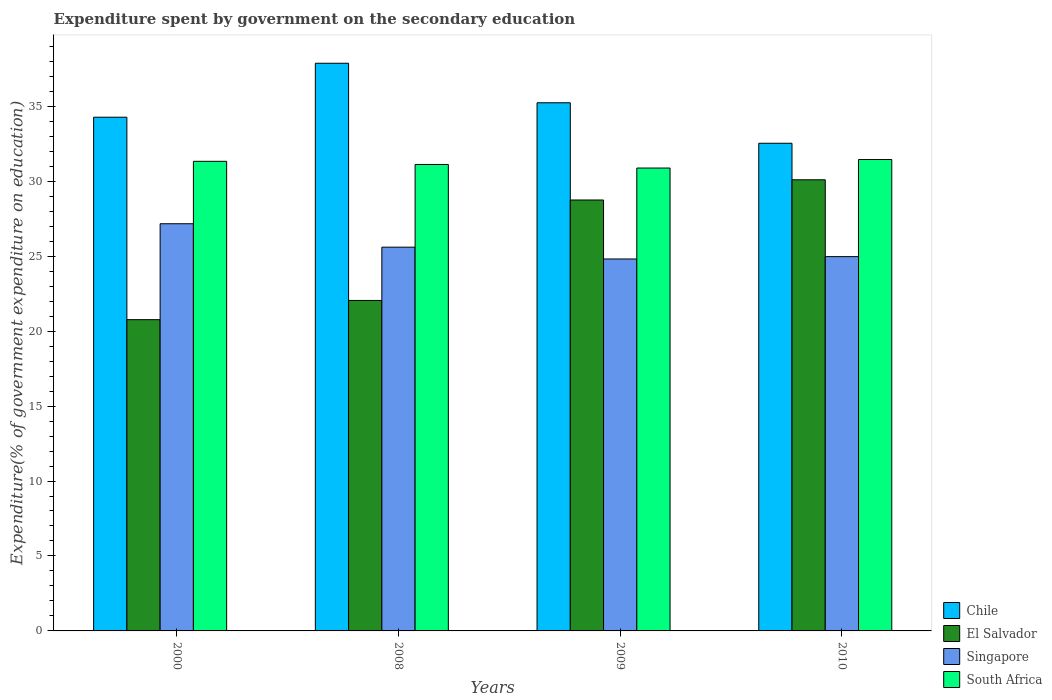Are the number of bars on each tick of the X-axis equal?
Make the answer very short. Yes. How many bars are there on the 3rd tick from the left?
Ensure brevity in your answer.  4. How many bars are there on the 4th tick from the right?
Make the answer very short. 4. What is the expenditure spent by government on the secondary education in Singapore in 2008?
Your answer should be very brief. 25.6. Across all years, what is the maximum expenditure spent by government on the secondary education in South Africa?
Provide a succinct answer. 31.45. Across all years, what is the minimum expenditure spent by government on the secondary education in Chile?
Ensure brevity in your answer.  32.53. What is the total expenditure spent by government on the secondary education in El Salvador in the graph?
Offer a terse response. 101.65. What is the difference between the expenditure spent by government on the secondary education in El Salvador in 2000 and that in 2009?
Your answer should be compact. -7.98. What is the difference between the expenditure spent by government on the secondary education in El Salvador in 2000 and the expenditure spent by government on the secondary education in Singapore in 2009?
Ensure brevity in your answer.  -4.05. What is the average expenditure spent by government on the secondary education in South Africa per year?
Ensure brevity in your answer.  31.19. In the year 2009, what is the difference between the expenditure spent by government on the secondary education in Singapore and expenditure spent by government on the secondary education in Chile?
Your answer should be compact. -10.42. In how many years, is the expenditure spent by government on the secondary education in Chile greater than 20 %?
Your response must be concise. 4. What is the ratio of the expenditure spent by government on the secondary education in El Salvador in 2000 to that in 2010?
Give a very brief answer. 0.69. Is the expenditure spent by government on the secondary education in Chile in 2009 less than that in 2010?
Provide a succinct answer. No. Is the difference between the expenditure spent by government on the secondary education in Singapore in 2000 and 2010 greater than the difference between the expenditure spent by government on the secondary education in Chile in 2000 and 2010?
Your response must be concise. Yes. What is the difference between the highest and the second highest expenditure spent by government on the secondary education in South Africa?
Ensure brevity in your answer.  0.12. What is the difference between the highest and the lowest expenditure spent by government on the secondary education in Singapore?
Provide a succinct answer. 2.35. Is it the case that in every year, the sum of the expenditure spent by government on the secondary education in Singapore and expenditure spent by government on the secondary education in South Africa is greater than the sum of expenditure spent by government on the secondary education in Chile and expenditure spent by government on the secondary education in El Salvador?
Your response must be concise. No. What does the 4th bar from the right in 2000 represents?
Offer a terse response. Chile. Is it the case that in every year, the sum of the expenditure spent by government on the secondary education in Singapore and expenditure spent by government on the secondary education in South Africa is greater than the expenditure spent by government on the secondary education in Chile?
Your answer should be very brief. Yes. Are all the bars in the graph horizontal?
Keep it short and to the point. No. What is the title of the graph?
Offer a terse response. Expenditure spent by government on the secondary education. What is the label or title of the X-axis?
Provide a short and direct response. Years. What is the label or title of the Y-axis?
Make the answer very short. Expenditure(% of government expenditure on education). What is the Expenditure(% of government expenditure on education) of Chile in 2000?
Your answer should be very brief. 34.27. What is the Expenditure(% of government expenditure on education) of El Salvador in 2000?
Offer a terse response. 20.76. What is the Expenditure(% of government expenditure on education) of Singapore in 2000?
Your answer should be compact. 27.16. What is the Expenditure(% of government expenditure on education) in South Africa in 2000?
Provide a short and direct response. 31.33. What is the Expenditure(% of government expenditure on education) of Chile in 2008?
Offer a terse response. 37.87. What is the Expenditure(% of government expenditure on education) of El Salvador in 2008?
Your answer should be compact. 22.05. What is the Expenditure(% of government expenditure on education) in Singapore in 2008?
Your answer should be compact. 25.6. What is the Expenditure(% of government expenditure on education) of South Africa in 2008?
Provide a short and direct response. 31.12. What is the Expenditure(% of government expenditure on education) of Chile in 2009?
Your response must be concise. 35.23. What is the Expenditure(% of government expenditure on education) in El Salvador in 2009?
Provide a short and direct response. 28.75. What is the Expenditure(% of government expenditure on education) of Singapore in 2009?
Keep it short and to the point. 24.81. What is the Expenditure(% of government expenditure on education) in South Africa in 2009?
Offer a very short reply. 30.88. What is the Expenditure(% of government expenditure on education) in Chile in 2010?
Make the answer very short. 32.53. What is the Expenditure(% of government expenditure on education) in El Salvador in 2010?
Provide a succinct answer. 30.09. What is the Expenditure(% of government expenditure on education) of Singapore in 2010?
Give a very brief answer. 24.97. What is the Expenditure(% of government expenditure on education) in South Africa in 2010?
Your response must be concise. 31.45. Across all years, what is the maximum Expenditure(% of government expenditure on education) in Chile?
Your answer should be compact. 37.87. Across all years, what is the maximum Expenditure(% of government expenditure on education) in El Salvador?
Provide a short and direct response. 30.09. Across all years, what is the maximum Expenditure(% of government expenditure on education) of Singapore?
Your answer should be compact. 27.16. Across all years, what is the maximum Expenditure(% of government expenditure on education) in South Africa?
Offer a terse response. 31.45. Across all years, what is the minimum Expenditure(% of government expenditure on education) of Chile?
Offer a terse response. 32.53. Across all years, what is the minimum Expenditure(% of government expenditure on education) of El Salvador?
Provide a short and direct response. 20.76. Across all years, what is the minimum Expenditure(% of government expenditure on education) in Singapore?
Ensure brevity in your answer.  24.81. Across all years, what is the minimum Expenditure(% of government expenditure on education) of South Africa?
Ensure brevity in your answer.  30.88. What is the total Expenditure(% of government expenditure on education) of Chile in the graph?
Offer a terse response. 139.9. What is the total Expenditure(% of government expenditure on education) in El Salvador in the graph?
Offer a terse response. 101.65. What is the total Expenditure(% of government expenditure on education) of Singapore in the graph?
Make the answer very short. 102.54. What is the total Expenditure(% of government expenditure on education) of South Africa in the graph?
Your response must be concise. 124.77. What is the difference between the Expenditure(% of government expenditure on education) of Chile in 2000 and that in 2008?
Your answer should be compact. -3.6. What is the difference between the Expenditure(% of government expenditure on education) in El Salvador in 2000 and that in 2008?
Ensure brevity in your answer.  -1.28. What is the difference between the Expenditure(% of government expenditure on education) of Singapore in 2000 and that in 2008?
Keep it short and to the point. 1.56. What is the difference between the Expenditure(% of government expenditure on education) in South Africa in 2000 and that in 2008?
Your answer should be very brief. 0.21. What is the difference between the Expenditure(% of government expenditure on education) in Chile in 2000 and that in 2009?
Your answer should be very brief. -0.96. What is the difference between the Expenditure(% of government expenditure on education) in El Salvador in 2000 and that in 2009?
Your response must be concise. -7.98. What is the difference between the Expenditure(% of government expenditure on education) in Singapore in 2000 and that in 2009?
Ensure brevity in your answer.  2.35. What is the difference between the Expenditure(% of government expenditure on education) of South Africa in 2000 and that in 2009?
Offer a terse response. 0.45. What is the difference between the Expenditure(% of government expenditure on education) of Chile in 2000 and that in 2010?
Keep it short and to the point. 1.74. What is the difference between the Expenditure(% of government expenditure on education) of El Salvador in 2000 and that in 2010?
Give a very brief answer. -9.33. What is the difference between the Expenditure(% of government expenditure on education) of Singapore in 2000 and that in 2010?
Offer a terse response. 2.19. What is the difference between the Expenditure(% of government expenditure on education) of South Africa in 2000 and that in 2010?
Give a very brief answer. -0.12. What is the difference between the Expenditure(% of government expenditure on education) in Chile in 2008 and that in 2009?
Ensure brevity in your answer.  2.64. What is the difference between the Expenditure(% of government expenditure on education) in El Salvador in 2008 and that in 2009?
Your answer should be compact. -6.7. What is the difference between the Expenditure(% of government expenditure on education) of Singapore in 2008 and that in 2009?
Offer a very short reply. 0.79. What is the difference between the Expenditure(% of government expenditure on education) in South Africa in 2008 and that in 2009?
Your answer should be compact. 0.24. What is the difference between the Expenditure(% of government expenditure on education) in Chile in 2008 and that in 2010?
Make the answer very short. 5.34. What is the difference between the Expenditure(% of government expenditure on education) of El Salvador in 2008 and that in 2010?
Make the answer very short. -8.05. What is the difference between the Expenditure(% of government expenditure on education) in Singapore in 2008 and that in 2010?
Your response must be concise. 0.63. What is the difference between the Expenditure(% of government expenditure on education) in South Africa in 2008 and that in 2010?
Your answer should be compact. -0.33. What is the difference between the Expenditure(% of government expenditure on education) in Chile in 2009 and that in 2010?
Provide a succinct answer. 2.7. What is the difference between the Expenditure(% of government expenditure on education) of El Salvador in 2009 and that in 2010?
Ensure brevity in your answer.  -1.35. What is the difference between the Expenditure(% of government expenditure on education) in Singapore in 2009 and that in 2010?
Offer a very short reply. -0.16. What is the difference between the Expenditure(% of government expenditure on education) of South Africa in 2009 and that in 2010?
Your response must be concise. -0.57. What is the difference between the Expenditure(% of government expenditure on education) of Chile in 2000 and the Expenditure(% of government expenditure on education) of El Salvador in 2008?
Offer a very short reply. 12.22. What is the difference between the Expenditure(% of government expenditure on education) in Chile in 2000 and the Expenditure(% of government expenditure on education) in Singapore in 2008?
Your answer should be very brief. 8.67. What is the difference between the Expenditure(% of government expenditure on education) of Chile in 2000 and the Expenditure(% of government expenditure on education) of South Africa in 2008?
Keep it short and to the point. 3.15. What is the difference between the Expenditure(% of government expenditure on education) in El Salvador in 2000 and the Expenditure(% of government expenditure on education) in Singapore in 2008?
Your answer should be compact. -4.84. What is the difference between the Expenditure(% of government expenditure on education) in El Salvador in 2000 and the Expenditure(% of government expenditure on education) in South Africa in 2008?
Make the answer very short. -10.35. What is the difference between the Expenditure(% of government expenditure on education) in Singapore in 2000 and the Expenditure(% of government expenditure on education) in South Africa in 2008?
Offer a terse response. -3.95. What is the difference between the Expenditure(% of government expenditure on education) of Chile in 2000 and the Expenditure(% of government expenditure on education) of El Salvador in 2009?
Offer a terse response. 5.52. What is the difference between the Expenditure(% of government expenditure on education) of Chile in 2000 and the Expenditure(% of government expenditure on education) of Singapore in 2009?
Your response must be concise. 9.46. What is the difference between the Expenditure(% of government expenditure on education) in Chile in 2000 and the Expenditure(% of government expenditure on education) in South Africa in 2009?
Provide a short and direct response. 3.39. What is the difference between the Expenditure(% of government expenditure on education) in El Salvador in 2000 and the Expenditure(% of government expenditure on education) in Singapore in 2009?
Your response must be concise. -4.05. What is the difference between the Expenditure(% of government expenditure on education) in El Salvador in 2000 and the Expenditure(% of government expenditure on education) in South Africa in 2009?
Offer a terse response. -10.11. What is the difference between the Expenditure(% of government expenditure on education) in Singapore in 2000 and the Expenditure(% of government expenditure on education) in South Africa in 2009?
Provide a short and direct response. -3.72. What is the difference between the Expenditure(% of government expenditure on education) in Chile in 2000 and the Expenditure(% of government expenditure on education) in El Salvador in 2010?
Your answer should be compact. 4.18. What is the difference between the Expenditure(% of government expenditure on education) of Chile in 2000 and the Expenditure(% of government expenditure on education) of Singapore in 2010?
Offer a very short reply. 9.3. What is the difference between the Expenditure(% of government expenditure on education) of Chile in 2000 and the Expenditure(% of government expenditure on education) of South Africa in 2010?
Keep it short and to the point. 2.82. What is the difference between the Expenditure(% of government expenditure on education) of El Salvador in 2000 and the Expenditure(% of government expenditure on education) of Singapore in 2010?
Provide a short and direct response. -4.2. What is the difference between the Expenditure(% of government expenditure on education) of El Salvador in 2000 and the Expenditure(% of government expenditure on education) of South Africa in 2010?
Your answer should be very brief. -10.69. What is the difference between the Expenditure(% of government expenditure on education) of Singapore in 2000 and the Expenditure(% of government expenditure on education) of South Africa in 2010?
Give a very brief answer. -4.29. What is the difference between the Expenditure(% of government expenditure on education) in Chile in 2008 and the Expenditure(% of government expenditure on education) in El Salvador in 2009?
Give a very brief answer. 9.12. What is the difference between the Expenditure(% of government expenditure on education) in Chile in 2008 and the Expenditure(% of government expenditure on education) in Singapore in 2009?
Offer a very short reply. 13.06. What is the difference between the Expenditure(% of government expenditure on education) in Chile in 2008 and the Expenditure(% of government expenditure on education) in South Africa in 2009?
Make the answer very short. 6.99. What is the difference between the Expenditure(% of government expenditure on education) of El Salvador in 2008 and the Expenditure(% of government expenditure on education) of Singapore in 2009?
Your answer should be very brief. -2.77. What is the difference between the Expenditure(% of government expenditure on education) of El Salvador in 2008 and the Expenditure(% of government expenditure on education) of South Africa in 2009?
Offer a terse response. -8.83. What is the difference between the Expenditure(% of government expenditure on education) in Singapore in 2008 and the Expenditure(% of government expenditure on education) in South Africa in 2009?
Your answer should be very brief. -5.28. What is the difference between the Expenditure(% of government expenditure on education) of Chile in 2008 and the Expenditure(% of government expenditure on education) of El Salvador in 2010?
Offer a terse response. 7.77. What is the difference between the Expenditure(% of government expenditure on education) of Chile in 2008 and the Expenditure(% of government expenditure on education) of Singapore in 2010?
Your answer should be very brief. 12.9. What is the difference between the Expenditure(% of government expenditure on education) in Chile in 2008 and the Expenditure(% of government expenditure on education) in South Africa in 2010?
Offer a terse response. 6.42. What is the difference between the Expenditure(% of government expenditure on education) of El Salvador in 2008 and the Expenditure(% of government expenditure on education) of Singapore in 2010?
Provide a succinct answer. -2.92. What is the difference between the Expenditure(% of government expenditure on education) of El Salvador in 2008 and the Expenditure(% of government expenditure on education) of South Africa in 2010?
Provide a short and direct response. -9.4. What is the difference between the Expenditure(% of government expenditure on education) of Singapore in 2008 and the Expenditure(% of government expenditure on education) of South Africa in 2010?
Provide a succinct answer. -5.85. What is the difference between the Expenditure(% of government expenditure on education) of Chile in 2009 and the Expenditure(% of government expenditure on education) of El Salvador in 2010?
Your response must be concise. 5.14. What is the difference between the Expenditure(% of government expenditure on education) in Chile in 2009 and the Expenditure(% of government expenditure on education) in Singapore in 2010?
Ensure brevity in your answer.  10.26. What is the difference between the Expenditure(% of government expenditure on education) of Chile in 2009 and the Expenditure(% of government expenditure on education) of South Africa in 2010?
Offer a terse response. 3.78. What is the difference between the Expenditure(% of government expenditure on education) of El Salvador in 2009 and the Expenditure(% of government expenditure on education) of Singapore in 2010?
Your response must be concise. 3.78. What is the difference between the Expenditure(% of government expenditure on education) in El Salvador in 2009 and the Expenditure(% of government expenditure on education) in South Africa in 2010?
Give a very brief answer. -2.7. What is the difference between the Expenditure(% of government expenditure on education) in Singapore in 2009 and the Expenditure(% of government expenditure on education) in South Africa in 2010?
Your response must be concise. -6.64. What is the average Expenditure(% of government expenditure on education) of Chile per year?
Keep it short and to the point. 34.98. What is the average Expenditure(% of government expenditure on education) in El Salvador per year?
Your answer should be compact. 25.41. What is the average Expenditure(% of government expenditure on education) of Singapore per year?
Ensure brevity in your answer.  25.64. What is the average Expenditure(% of government expenditure on education) in South Africa per year?
Your answer should be compact. 31.19. In the year 2000, what is the difference between the Expenditure(% of government expenditure on education) of Chile and Expenditure(% of government expenditure on education) of El Salvador?
Your response must be concise. 13.51. In the year 2000, what is the difference between the Expenditure(% of government expenditure on education) of Chile and Expenditure(% of government expenditure on education) of Singapore?
Ensure brevity in your answer.  7.11. In the year 2000, what is the difference between the Expenditure(% of government expenditure on education) in Chile and Expenditure(% of government expenditure on education) in South Africa?
Provide a short and direct response. 2.94. In the year 2000, what is the difference between the Expenditure(% of government expenditure on education) in El Salvador and Expenditure(% of government expenditure on education) in Singapore?
Make the answer very short. -6.4. In the year 2000, what is the difference between the Expenditure(% of government expenditure on education) in El Salvador and Expenditure(% of government expenditure on education) in South Africa?
Make the answer very short. -10.56. In the year 2000, what is the difference between the Expenditure(% of government expenditure on education) in Singapore and Expenditure(% of government expenditure on education) in South Africa?
Your response must be concise. -4.16. In the year 2008, what is the difference between the Expenditure(% of government expenditure on education) in Chile and Expenditure(% of government expenditure on education) in El Salvador?
Ensure brevity in your answer.  15.82. In the year 2008, what is the difference between the Expenditure(% of government expenditure on education) of Chile and Expenditure(% of government expenditure on education) of Singapore?
Ensure brevity in your answer.  12.27. In the year 2008, what is the difference between the Expenditure(% of government expenditure on education) in Chile and Expenditure(% of government expenditure on education) in South Africa?
Offer a terse response. 6.75. In the year 2008, what is the difference between the Expenditure(% of government expenditure on education) of El Salvador and Expenditure(% of government expenditure on education) of Singapore?
Your answer should be compact. -3.55. In the year 2008, what is the difference between the Expenditure(% of government expenditure on education) of El Salvador and Expenditure(% of government expenditure on education) of South Africa?
Ensure brevity in your answer.  -9.07. In the year 2008, what is the difference between the Expenditure(% of government expenditure on education) of Singapore and Expenditure(% of government expenditure on education) of South Africa?
Your answer should be compact. -5.52. In the year 2009, what is the difference between the Expenditure(% of government expenditure on education) of Chile and Expenditure(% of government expenditure on education) of El Salvador?
Your answer should be very brief. 6.48. In the year 2009, what is the difference between the Expenditure(% of government expenditure on education) of Chile and Expenditure(% of government expenditure on education) of Singapore?
Offer a very short reply. 10.42. In the year 2009, what is the difference between the Expenditure(% of government expenditure on education) in Chile and Expenditure(% of government expenditure on education) in South Africa?
Provide a short and direct response. 4.35. In the year 2009, what is the difference between the Expenditure(% of government expenditure on education) in El Salvador and Expenditure(% of government expenditure on education) in Singapore?
Ensure brevity in your answer.  3.94. In the year 2009, what is the difference between the Expenditure(% of government expenditure on education) of El Salvador and Expenditure(% of government expenditure on education) of South Africa?
Your answer should be very brief. -2.13. In the year 2009, what is the difference between the Expenditure(% of government expenditure on education) in Singapore and Expenditure(% of government expenditure on education) in South Africa?
Your answer should be compact. -6.07. In the year 2010, what is the difference between the Expenditure(% of government expenditure on education) in Chile and Expenditure(% of government expenditure on education) in El Salvador?
Ensure brevity in your answer.  2.44. In the year 2010, what is the difference between the Expenditure(% of government expenditure on education) of Chile and Expenditure(% of government expenditure on education) of Singapore?
Make the answer very short. 7.56. In the year 2010, what is the difference between the Expenditure(% of government expenditure on education) of Chile and Expenditure(% of government expenditure on education) of South Africa?
Make the answer very short. 1.08. In the year 2010, what is the difference between the Expenditure(% of government expenditure on education) in El Salvador and Expenditure(% of government expenditure on education) in Singapore?
Provide a short and direct response. 5.13. In the year 2010, what is the difference between the Expenditure(% of government expenditure on education) in El Salvador and Expenditure(% of government expenditure on education) in South Africa?
Your answer should be compact. -1.35. In the year 2010, what is the difference between the Expenditure(% of government expenditure on education) of Singapore and Expenditure(% of government expenditure on education) of South Africa?
Offer a very short reply. -6.48. What is the ratio of the Expenditure(% of government expenditure on education) of Chile in 2000 to that in 2008?
Give a very brief answer. 0.91. What is the ratio of the Expenditure(% of government expenditure on education) in El Salvador in 2000 to that in 2008?
Your response must be concise. 0.94. What is the ratio of the Expenditure(% of government expenditure on education) in Singapore in 2000 to that in 2008?
Offer a very short reply. 1.06. What is the ratio of the Expenditure(% of government expenditure on education) in South Africa in 2000 to that in 2008?
Keep it short and to the point. 1.01. What is the ratio of the Expenditure(% of government expenditure on education) of Chile in 2000 to that in 2009?
Offer a very short reply. 0.97. What is the ratio of the Expenditure(% of government expenditure on education) in El Salvador in 2000 to that in 2009?
Your answer should be very brief. 0.72. What is the ratio of the Expenditure(% of government expenditure on education) of Singapore in 2000 to that in 2009?
Make the answer very short. 1.09. What is the ratio of the Expenditure(% of government expenditure on education) of South Africa in 2000 to that in 2009?
Your answer should be very brief. 1.01. What is the ratio of the Expenditure(% of government expenditure on education) of Chile in 2000 to that in 2010?
Your answer should be compact. 1.05. What is the ratio of the Expenditure(% of government expenditure on education) of El Salvador in 2000 to that in 2010?
Keep it short and to the point. 0.69. What is the ratio of the Expenditure(% of government expenditure on education) of Singapore in 2000 to that in 2010?
Give a very brief answer. 1.09. What is the ratio of the Expenditure(% of government expenditure on education) in South Africa in 2000 to that in 2010?
Offer a very short reply. 1. What is the ratio of the Expenditure(% of government expenditure on education) in Chile in 2008 to that in 2009?
Provide a succinct answer. 1.07. What is the ratio of the Expenditure(% of government expenditure on education) in El Salvador in 2008 to that in 2009?
Give a very brief answer. 0.77. What is the ratio of the Expenditure(% of government expenditure on education) in Singapore in 2008 to that in 2009?
Give a very brief answer. 1.03. What is the ratio of the Expenditure(% of government expenditure on education) in South Africa in 2008 to that in 2009?
Ensure brevity in your answer.  1.01. What is the ratio of the Expenditure(% of government expenditure on education) of Chile in 2008 to that in 2010?
Provide a succinct answer. 1.16. What is the ratio of the Expenditure(% of government expenditure on education) of El Salvador in 2008 to that in 2010?
Your answer should be very brief. 0.73. What is the ratio of the Expenditure(% of government expenditure on education) in Singapore in 2008 to that in 2010?
Give a very brief answer. 1.03. What is the ratio of the Expenditure(% of government expenditure on education) of Chile in 2009 to that in 2010?
Your answer should be compact. 1.08. What is the ratio of the Expenditure(% of government expenditure on education) of El Salvador in 2009 to that in 2010?
Provide a succinct answer. 0.96. What is the ratio of the Expenditure(% of government expenditure on education) of Singapore in 2009 to that in 2010?
Make the answer very short. 0.99. What is the ratio of the Expenditure(% of government expenditure on education) in South Africa in 2009 to that in 2010?
Make the answer very short. 0.98. What is the difference between the highest and the second highest Expenditure(% of government expenditure on education) of Chile?
Ensure brevity in your answer.  2.64. What is the difference between the highest and the second highest Expenditure(% of government expenditure on education) of El Salvador?
Provide a succinct answer. 1.35. What is the difference between the highest and the second highest Expenditure(% of government expenditure on education) of Singapore?
Ensure brevity in your answer.  1.56. What is the difference between the highest and the second highest Expenditure(% of government expenditure on education) of South Africa?
Provide a succinct answer. 0.12. What is the difference between the highest and the lowest Expenditure(% of government expenditure on education) of Chile?
Offer a terse response. 5.34. What is the difference between the highest and the lowest Expenditure(% of government expenditure on education) of El Salvador?
Keep it short and to the point. 9.33. What is the difference between the highest and the lowest Expenditure(% of government expenditure on education) in Singapore?
Offer a terse response. 2.35. What is the difference between the highest and the lowest Expenditure(% of government expenditure on education) of South Africa?
Offer a very short reply. 0.57. 